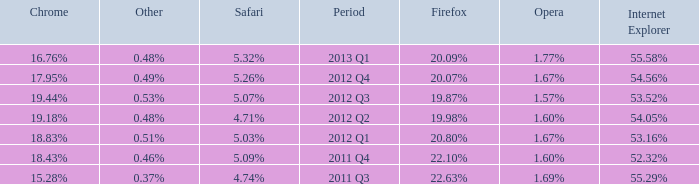Could you parse the entire table as a dict? {'header': ['Chrome', 'Other', 'Safari', 'Period', 'Firefox', 'Opera', 'Internet Explorer'], 'rows': [['16.76%', '0.48%', '5.32%', '2013 Q1', '20.09%', '1.77%', '55.58%'], ['17.95%', '0.49%', '5.26%', '2012 Q4', '20.07%', '1.67%', '54.56%'], ['19.44%', '0.53%', '5.07%', '2012 Q3', '19.87%', '1.57%', '53.52%'], ['19.18%', '0.48%', '4.71%', '2012 Q2', '19.98%', '1.60%', '54.05%'], ['18.83%', '0.51%', '5.03%', '2012 Q1', '20.80%', '1.67%', '53.16%'], ['18.43%', '0.46%', '5.09%', '2011 Q4', '22.10%', '1.60%', '52.32%'], ['15.28%', '0.37%', '4.74%', '2011 Q3', '22.63%', '1.69%', '55.29%']]} What safari has 2012 q4 as the period? 5.26%. 